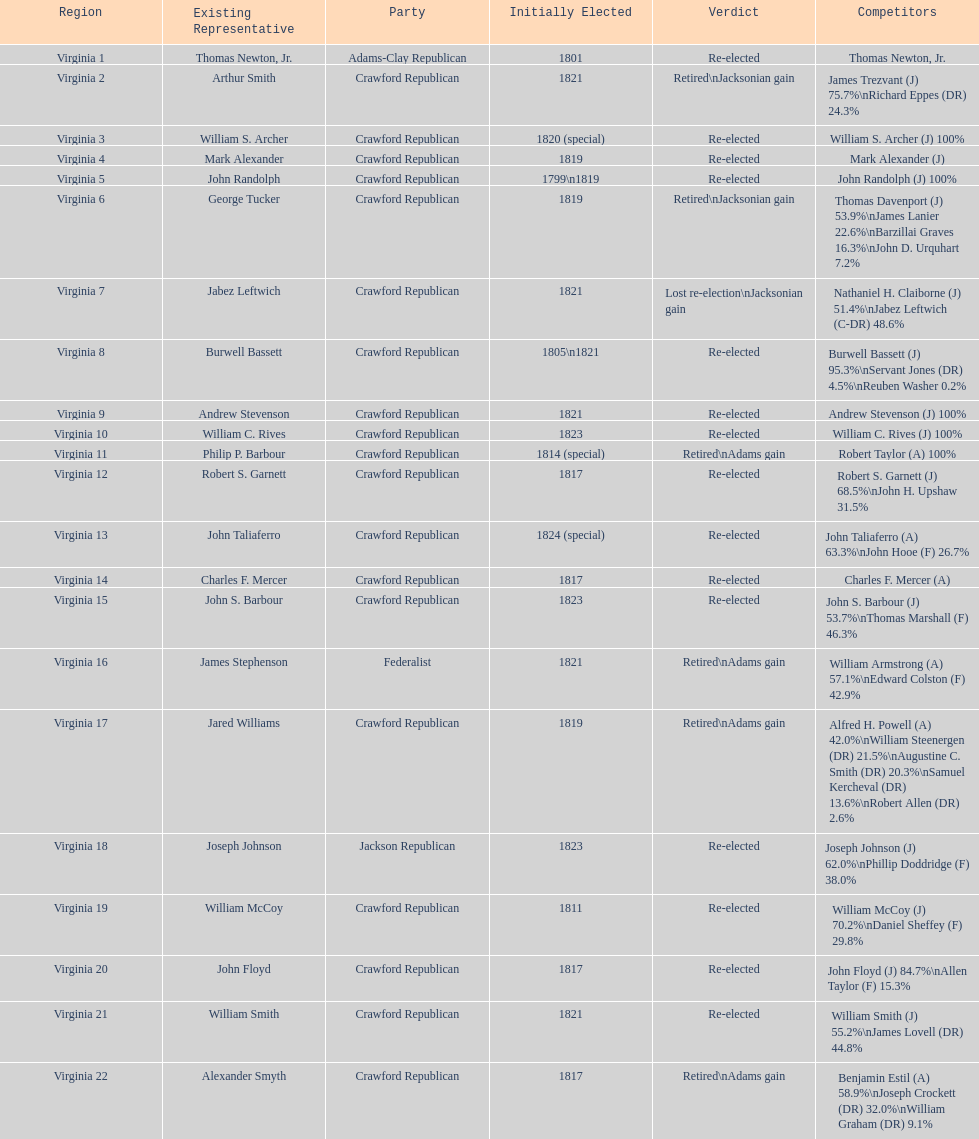Tell me the number of people first elected in 1817. 4. 